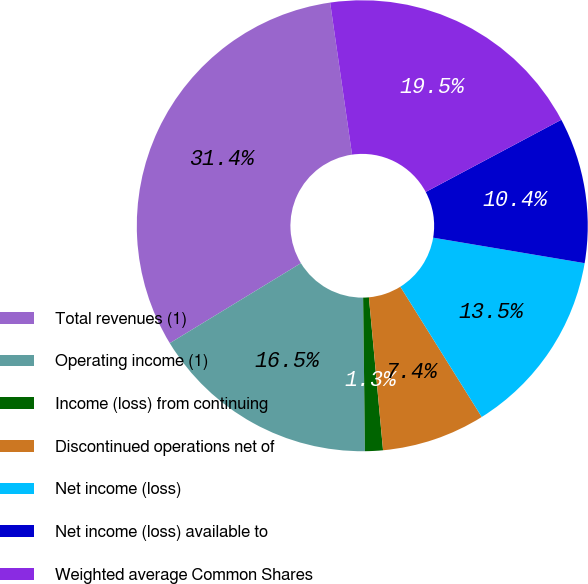Convert chart to OTSL. <chart><loc_0><loc_0><loc_500><loc_500><pie_chart><fcel>Total revenues (1)<fcel>Operating income (1)<fcel>Income (loss) from continuing<fcel>Discontinued operations net of<fcel>Net income (loss)<fcel>Net income (loss) available to<fcel>Weighted average Common Shares<nl><fcel>31.44%<fcel>16.47%<fcel>1.28%<fcel>7.42%<fcel>13.46%<fcel>10.44%<fcel>19.49%<nl></chart> 